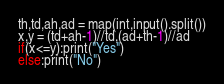Convert code to text. <code><loc_0><loc_0><loc_500><loc_500><_Python_>th,td,ah,ad = map(int,input().split())
x,y = (td+ah-1)//td,(ad+th-1)//ad
if(x<=y):print("Yes")
else:print("No")
</code> 